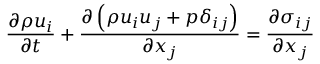Convert formula to latex. <formula><loc_0><loc_0><loc_500><loc_500>\frac { \partial \rho u _ { i } } { \partial t } + \frac { \partial \left ( \rho u _ { i } u _ { j } + p \delta _ { i j } \right ) } { \partial x _ { j } } = \frac { \partial \sigma _ { i j } } { \partial x _ { j } }</formula> 